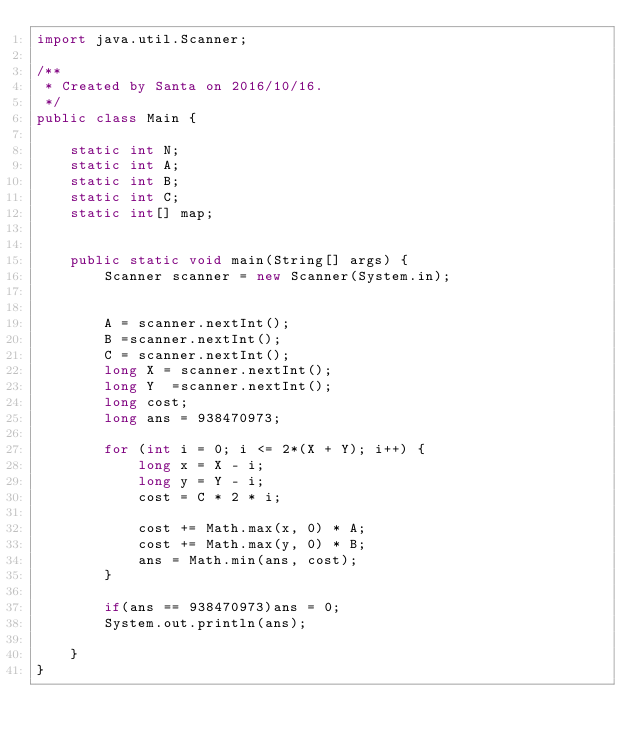<code> <loc_0><loc_0><loc_500><loc_500><_Java_>import java.util.Scanner;

/**
 * Created by Santa on 2016/10/16.
 */
public class Main {

    static int N;
    static int A;
    static int B;
    static int C;
    static int[] map;


    public static void main(String[] args) {
        Scanner scanner = new Scanner(System.in);


        A = scanner.nextInt();
        B =scanner.nextInt();
        C = scanner.nextInt();
        long X = scanner.nextInt();
        long Y  =scanner.nextInt();
        long cost;
        long ans = 938470973;

        for (int i = 0; i <= 2*(X + Y); i++) {
            long x = X - i;
            long y = Y - i;
            cost = C * 2 * i;

            cost += Math.max(x, 0) * A;
            cost += Math.max(y, 0) * B;
            ans = Math.min(ans, cost);
        }
        
        if(ans == 938470973)ans = 0;
        System.out.println(ans);
        
    }
}

</code> 